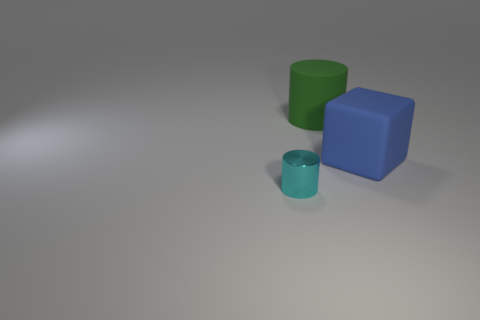Are there any other things that have the same material as the small cylinder?
Ensure brevity in your answer.  No. What number of things are in front of the green matte cylinder and behind the metallic object?
Your response must be concise. 1. How many objects are either tiny gray metal things or things that are behind the matte cube?
Your answer should be compact. 1. There is a blue cube that is made of the same material as the big cylinder; what is its size?
Offer a terse response. Large. There is a object that is on the left side of the big rubber object that is behind the large blue rubber cube; what is its shape?
Make the answer very short. Cylinder. How many cyan things are tiny metal cylinders or big rubber cylinders?
Your answer should be compact. 1. Is there a blue block behind the cylinder on the right side of the cylinder that is in front of the big green matte object?
Make the answer very short. No. What number of tiny things are either blue things or green cylinders?
Give a very brief answer. 0. Does the big object behind the big blue block have the same shape as the blue thing?
Offer a very short reply. No. Are there fewer large cubes than tiny green blocks?
Offer a terse response. No. 